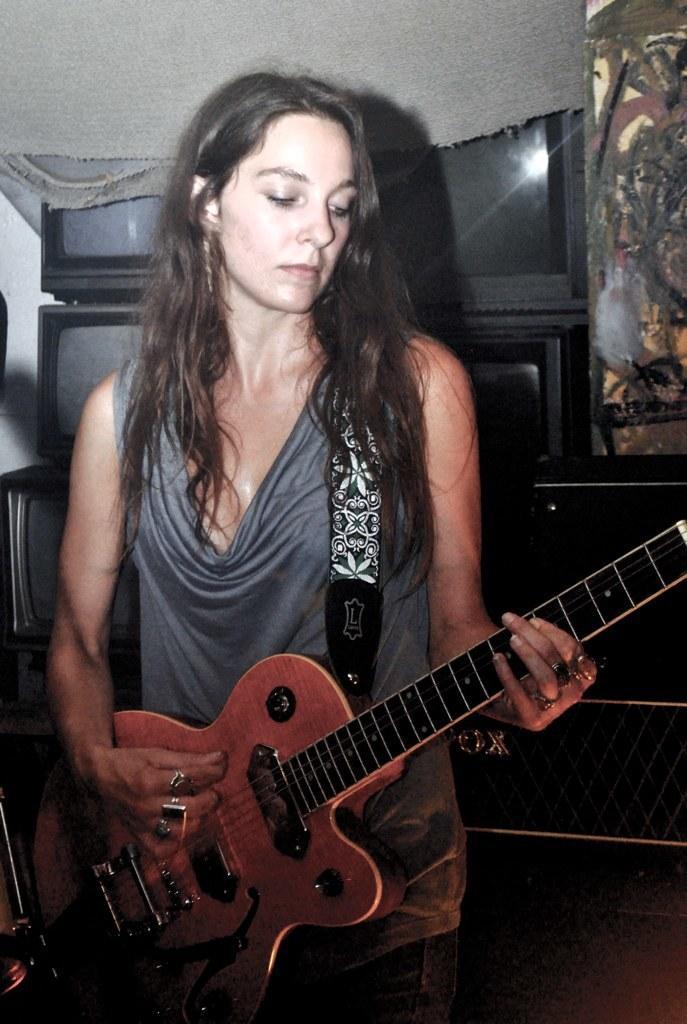In one or two sentences, can you explain what this image depicts? In this image, there is a person standing and playing a guitar. This person is wearing clothes. There are some televisions behind this person. 